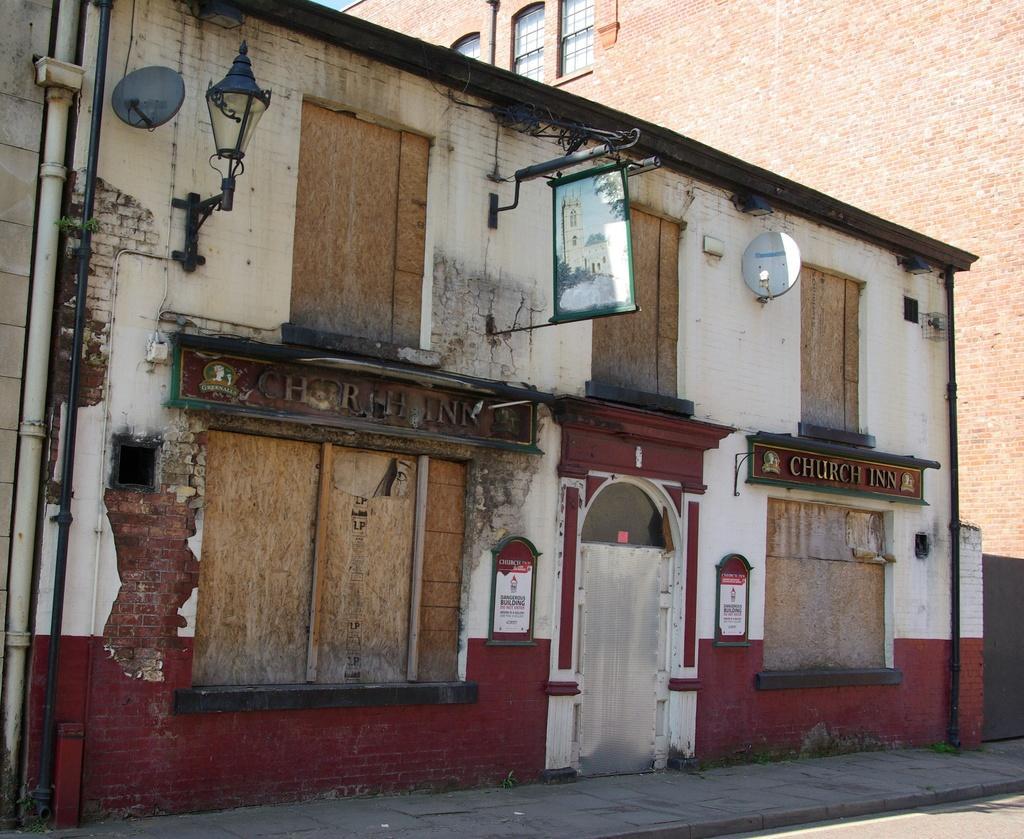How would you summarize this image in a sentence or two? At the center of the image there is a building with red bricks. On the building there is a lamp and some banner. In front of the building there is a road. 